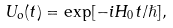<formula> <loc_0><loc_0><loc_500><loc_500>U _ { o } ( t ) = \exp [ - i H _ { 0 } t / \hslash ] ,</formula> 